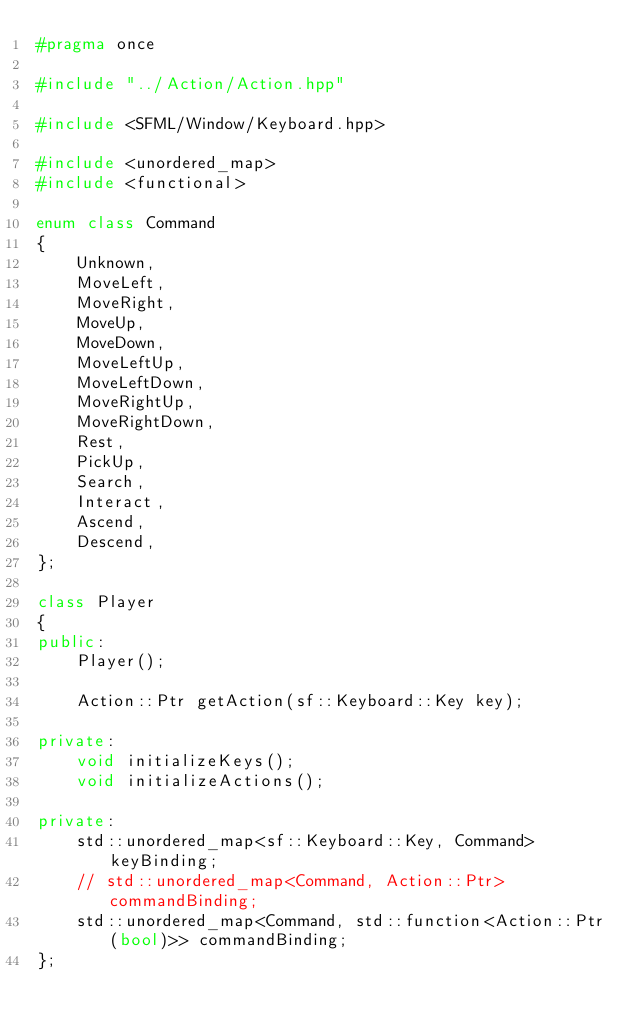Convert code to text. <code><loc_0><loc_0><loc_500><loc_500><_C++_>#pragma once

#include "../Action/Action.hpp"

#include <SFML/Window/Keyboard.hpp>

#include <unordered_map>
#include <functional>

enum class Command
{
	Unknown,
	MoveLeft,
	MoveRight,
	MoveUp,
	MoveDown,
	MoveLeftUp,
	MoveLeftDown,
	MoveRightUp,
	MoveRightDown,
	Rest,
	PickUp,
	Search,
	Interact,
	Ascend,
	Descend,
};

class Player
{
public:
	Player();

	Action::Ptr getAction(sf::Keyboard::Key key);

private:
	void initializeKeys();
	void initializeActions();

private:
	std::unordered_map<sf::Keyboard::Key, Command> keyBinding;
	// std::unordered_map<Command, Action::Ptr> commandBinding;
	std::unordered_map<Command, std::function<Action::Ptr(bool)>> commandBinding;
};
</code> 